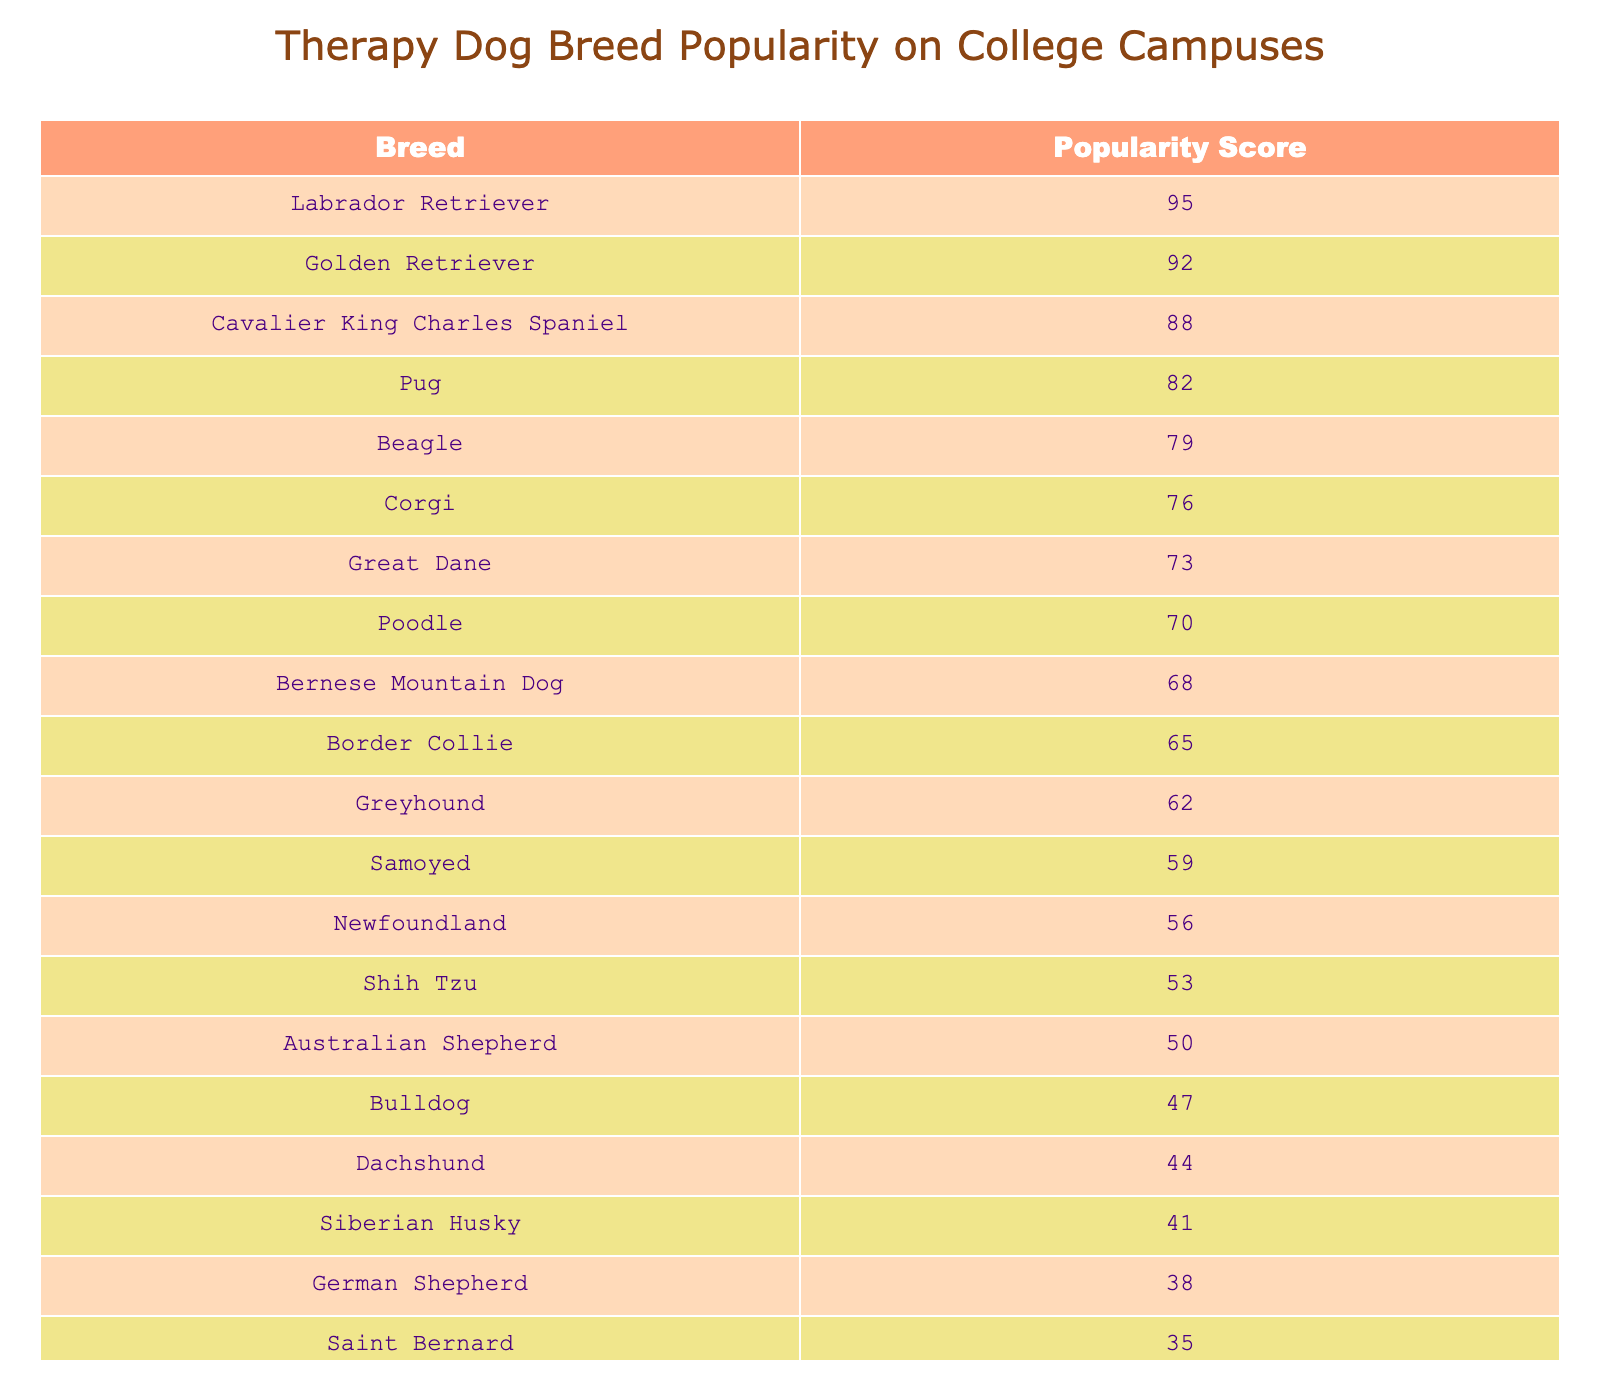What breed has the highest popularity score? Looking at the popularity scores, the breed with the highest score is the Labrador Retriever with a score of 95.
Answer: Labrador Retriever What is the popularity score of the Pug? The popularity score for the Pug can be found directly in the table, which shows that it has a score of 82.
Answer: 82 Which breed has a score of 65? By examining the table, the breed that has a popularity score of 65 is the Border Collie.
Answer: Border Collie How many breeds have a popularity score above 70? We need to look through the scores and count how many exceed 70. The breeds with scores above 70 are: Labrador Retriever (95), Golden Retriever (92), Cavalier King Charles Spaniel (88), Pug (82), Beagle (79), and Corgi (76). That gives us a total of 6 breeds.
Answer: 6 Is the popularity score of the Great Dane higher than 75? From the table, the Great Dane has a score of 73, which is less than 75, so the statement is false.
Answer: No What is the average popularity score of the top three breeds? The top three breeds are Labrador Retriever (95), Golden Retriever (92), and Cavalier King Charles Spaniel (88). First, we sum their scores: 95 + 92 + 88 = 275. There are 3 breeds, so we divide by 3 to get the average: 275 / 3 = 91.67.
Answer: 91.67 How much lower is the Newfoundland's score compared to the Labrador Retriever's score? The Newfoundland has a score of 56, while the Labrador Retriever has a score of 95. To find the difference, we subtract the Newfoundland's score from the Labrador Retriever's score: 95 - 56 = 39.
Answer: 39 Which breed ranks lowest in popularity score, and what is that score? By checking the scores in the table, the breed with the lowest score is the Saint Bernard with a popularity score of 35.
Answer: Saint Bernard, 35 If we combine the scores of the Beagle and the Bulldog, what is the total? The Beagle has a score of 79 and the Bulldog has a score of 47. Adding these together: 79 + 47 = 126.
Answer: 126 How does the Siberian Husky's score compare to the Poodle's score? The Siberian Husky has a score of 41 and the Poodle has a score of 70. Since 41 is less than 70, the Siberian Husky's score is lower than the Poodle's score.
Answer: Lower What is the combined popularity score of the top five breeds? The top five breeds are Labrador Retriever (95), Golden Retriever (92), Cavalier King Charles Spaniel (88), Pug (82), and Beagle (79). Adding these scores, we get: 95 + 92 + 88 + 82 + 79 = 436.
Answer: 436 